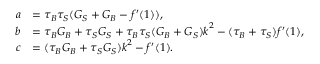Convert formula to latex. <formula><loc_0><loc_0><loc_500><loc_500>\begin{array} { r l } { a } & { = \tau _ { B } \tau _ { S } ( G _ { S } + G _ { B } - f ^ { \prime } ( 1 ) ) , } \\ { b } & { = \tau _ { B } G _ { B } + \tau _ { S } G _ { S } + \tau _ { B } \tau _ { S } ( G _ { B } + G _ { S } ) k ^ { 2 } - ( \tau _ { B } + \tau _ { S } ) f ^ { \prime } ( 1 ) , } \\ { c } & { = ( \tau _ { B } G _ { B } + \tau _ { S } G _ { S } ) k ^ { 2 } - f ^ { \prime } ( 1 ) . } \end{array}</formula> 